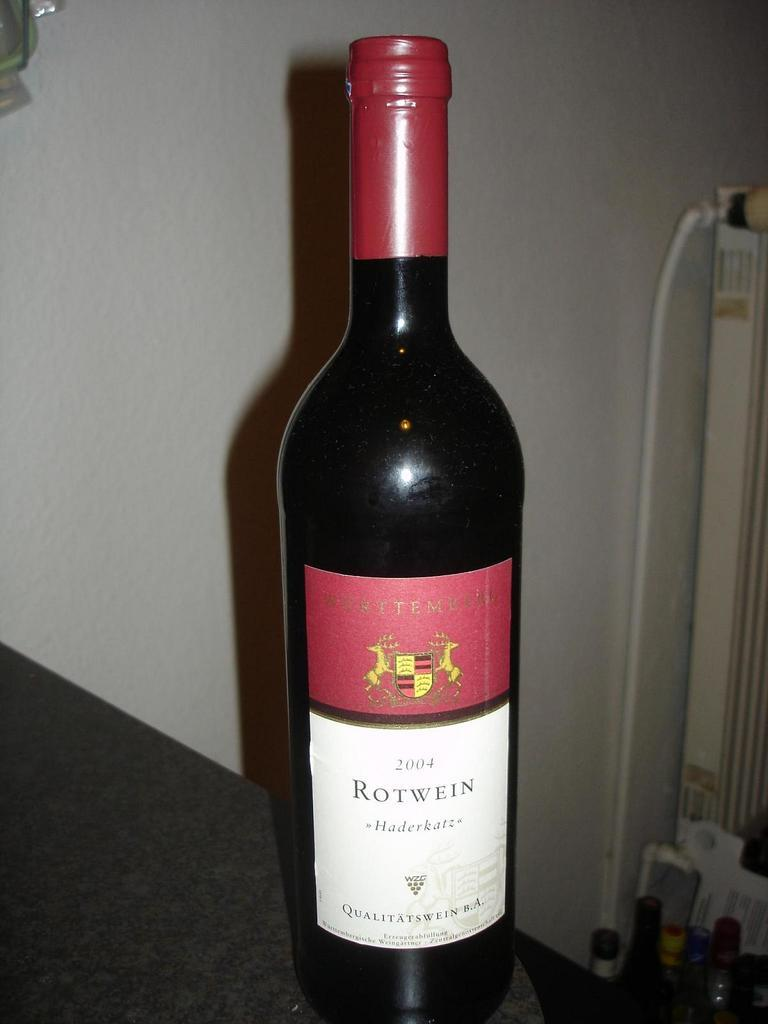<image>
Give a short and clear explanation of the subsequent image. A bottle is dated with the year 2004 and has a red and white label. 